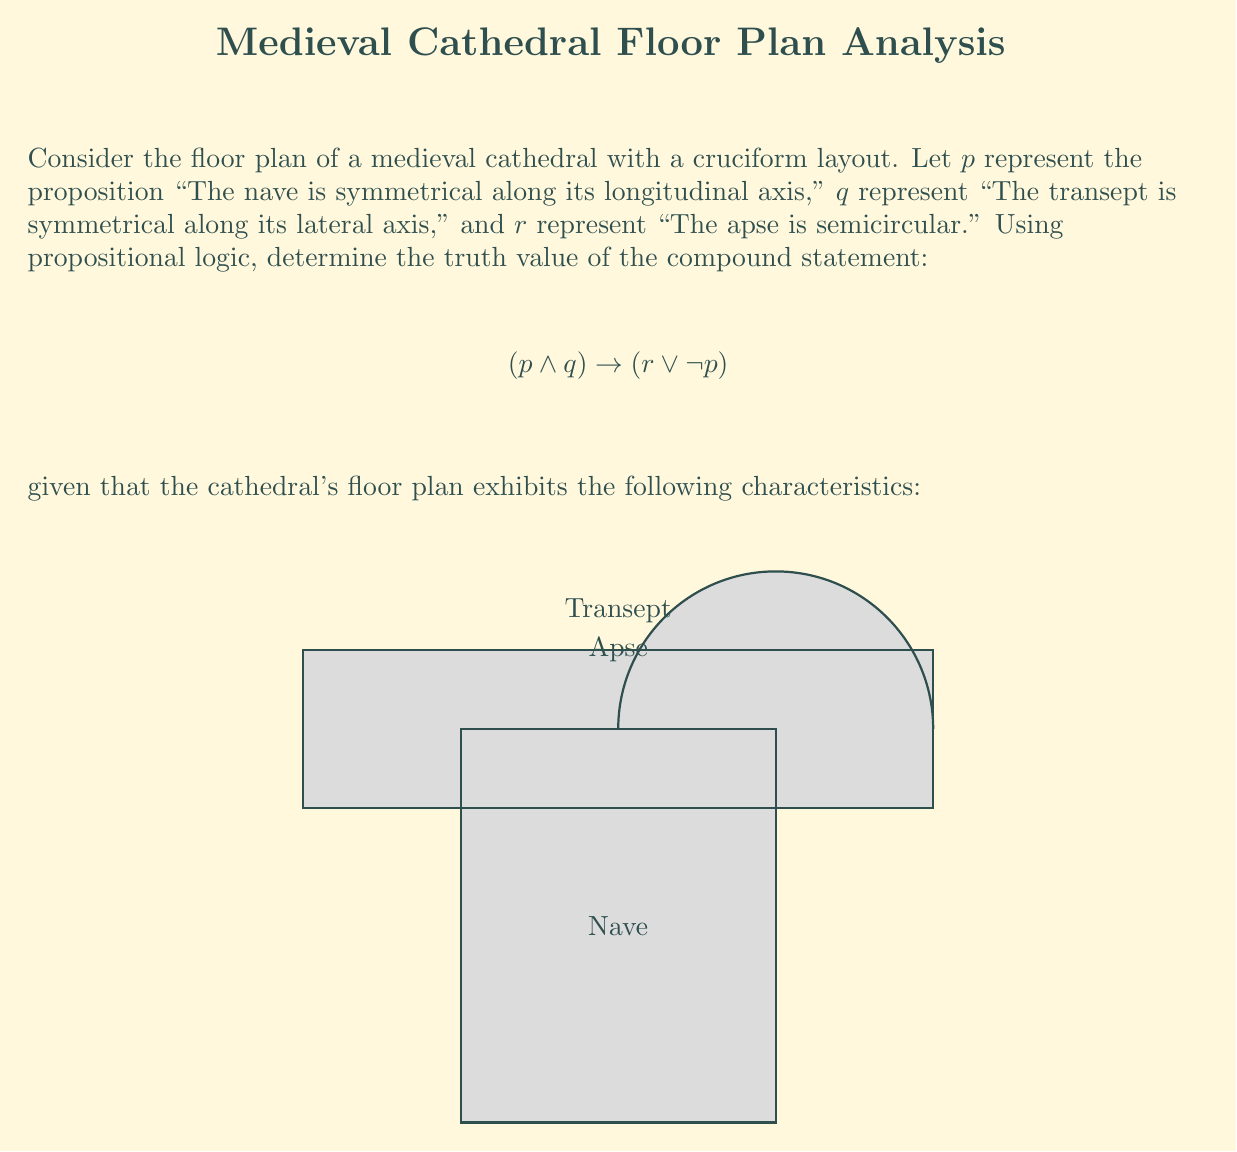Solve this math problem. Let's approach this step-by-step:

1) First, we need to determine the truth values of the individual propositions:

   $p$: "The nave is symmetrical along its longitudinal axis"
   From the diagram, we can see that the nave is indeed symmetrical. So, $p$ is true.

   $q$: "The transept is symmetrical along its lateral axis"
   The transept also appears symmetrical in the diagram. So, $q$ is true.

   $r$: "The apse is semicircular"
   The apse is shown as a semicircle in the diagram. So, $r$ is true.

2) Now, let's evaluate the compound statement:

   $$(p \land q) \rightarrow (r \lor \neg p)$$

3) We can break this down:
   
   - $(p \land q)$ is true, because both $p$ and $q$ are true.
   - $(r \lor \neg p)$ is true, because $r$ is true (regardless of the value of $\neg p$).

4) Recall the truth table for implication ($\rightarrow$):

   | $P$ | $Q$ | $P \rightarrow Q$ |
   |-----|-----|-------------------|
   | T   | T   | T                 |
   | T   | F   | F                 |
   | F   | T   | T                 |
   | F   | F   | T                 |

5) In our case, both the antecedent $(p \land q)$ and the consequent $(r \lor \neg p)$ are true.

6) Therefore, the entire statement $(p \land q) \rightarrow (r \lor \neg p)$ is true.

This logical analysis reflects the common symmetrical design principles in medieval cathedral architecture, where the nave and transept often exhibited bilateral symmetry, and the apse was frequently semicircular.
Answer: True 